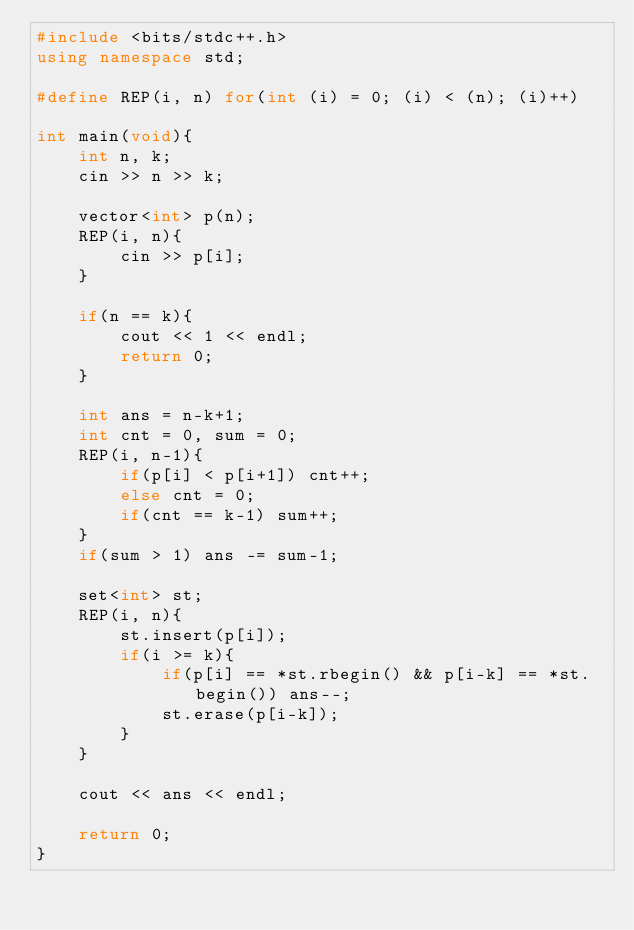<code> <loc_0><loc_0><loc_500><loc_500><_C++_>#include <bits/stdc++.h>
using namespace std;

#define REP(i, n) for(int (i) = 0; (i) < (n); (i)++)

int main(void){
	int n, k;
	cin >> n >> k;

	vector<int> p(n);
	REP(i, n){
		cin >> p[i];
	}

	if(n == k){
		cout << 1 << endl;
		return 0;
	}

	int ans = n-k+1;
	int cnt = 0, sum = 0;
	REP(i, n-1){
		if(p[i] < p[i+1]) cnt++;
		else cnt = 0;
		if(cnt == k-1) sum++;
	}
	if(sum > 1) ans -= sum-1;

	set<int> st;
	REP(i, n){
		st.insert(p[i]);
		if(i >= k){
			if(p[i] == *st.rbegin() && p[i-k] == *st.begin()) ans--;
			st.erase(p[i-k]);
		}
	}

	cout << ans << endl;

	return 0;
}
</code> 